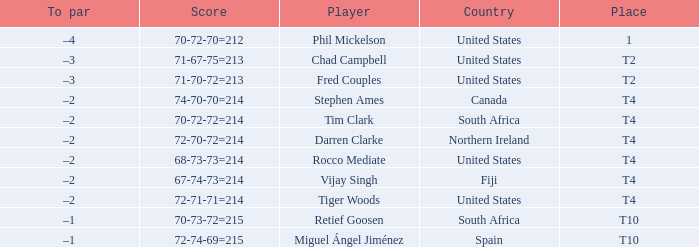Where is Fred Couples from? United States. 